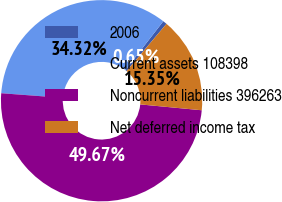Convert chart. <chart><loc_0><loc_0><loc_500><loc_500><pie_chart><fcel>2006<fcel>Current assets 108398<fcel>Noncurrent liabilities 396263<fcel>Net deferred income tax<nl><fcel>0.65%<fcel>34.32%<fcel>49.67%<fcel>15.35%<nl></chart> 